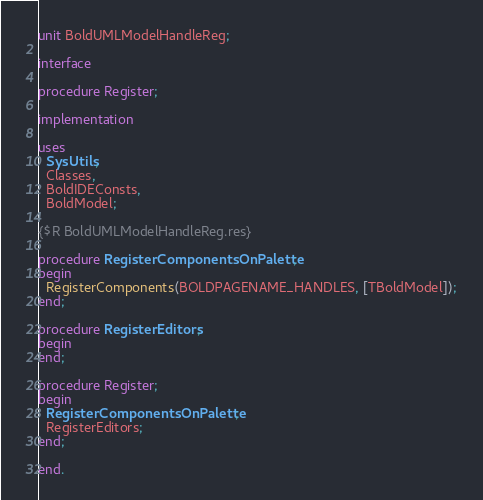Convert code to text. <code><loc_0><loc_0><loc_500><loc_500><_Pascal_>unit BoldUMLModelHandleReg;

interface

procedure Register;

implementation

uses
  SysUtils,
  Classes,
  BoldIDEConsts,
  BoldModel;

{$R BoldUMLModelHandleReg.res}

procedure RegisterComponentsOnPalette;
begin
  RegisterComponents(BOLDPAGENAME_HANDLES, [TBoldModel]);
end;

procedure RegisterEditors;
begin
end;

procedure Register;
begin
  RegisterComponentsOnPalette;
  RegisterEditors;
end;

end.
</code> 